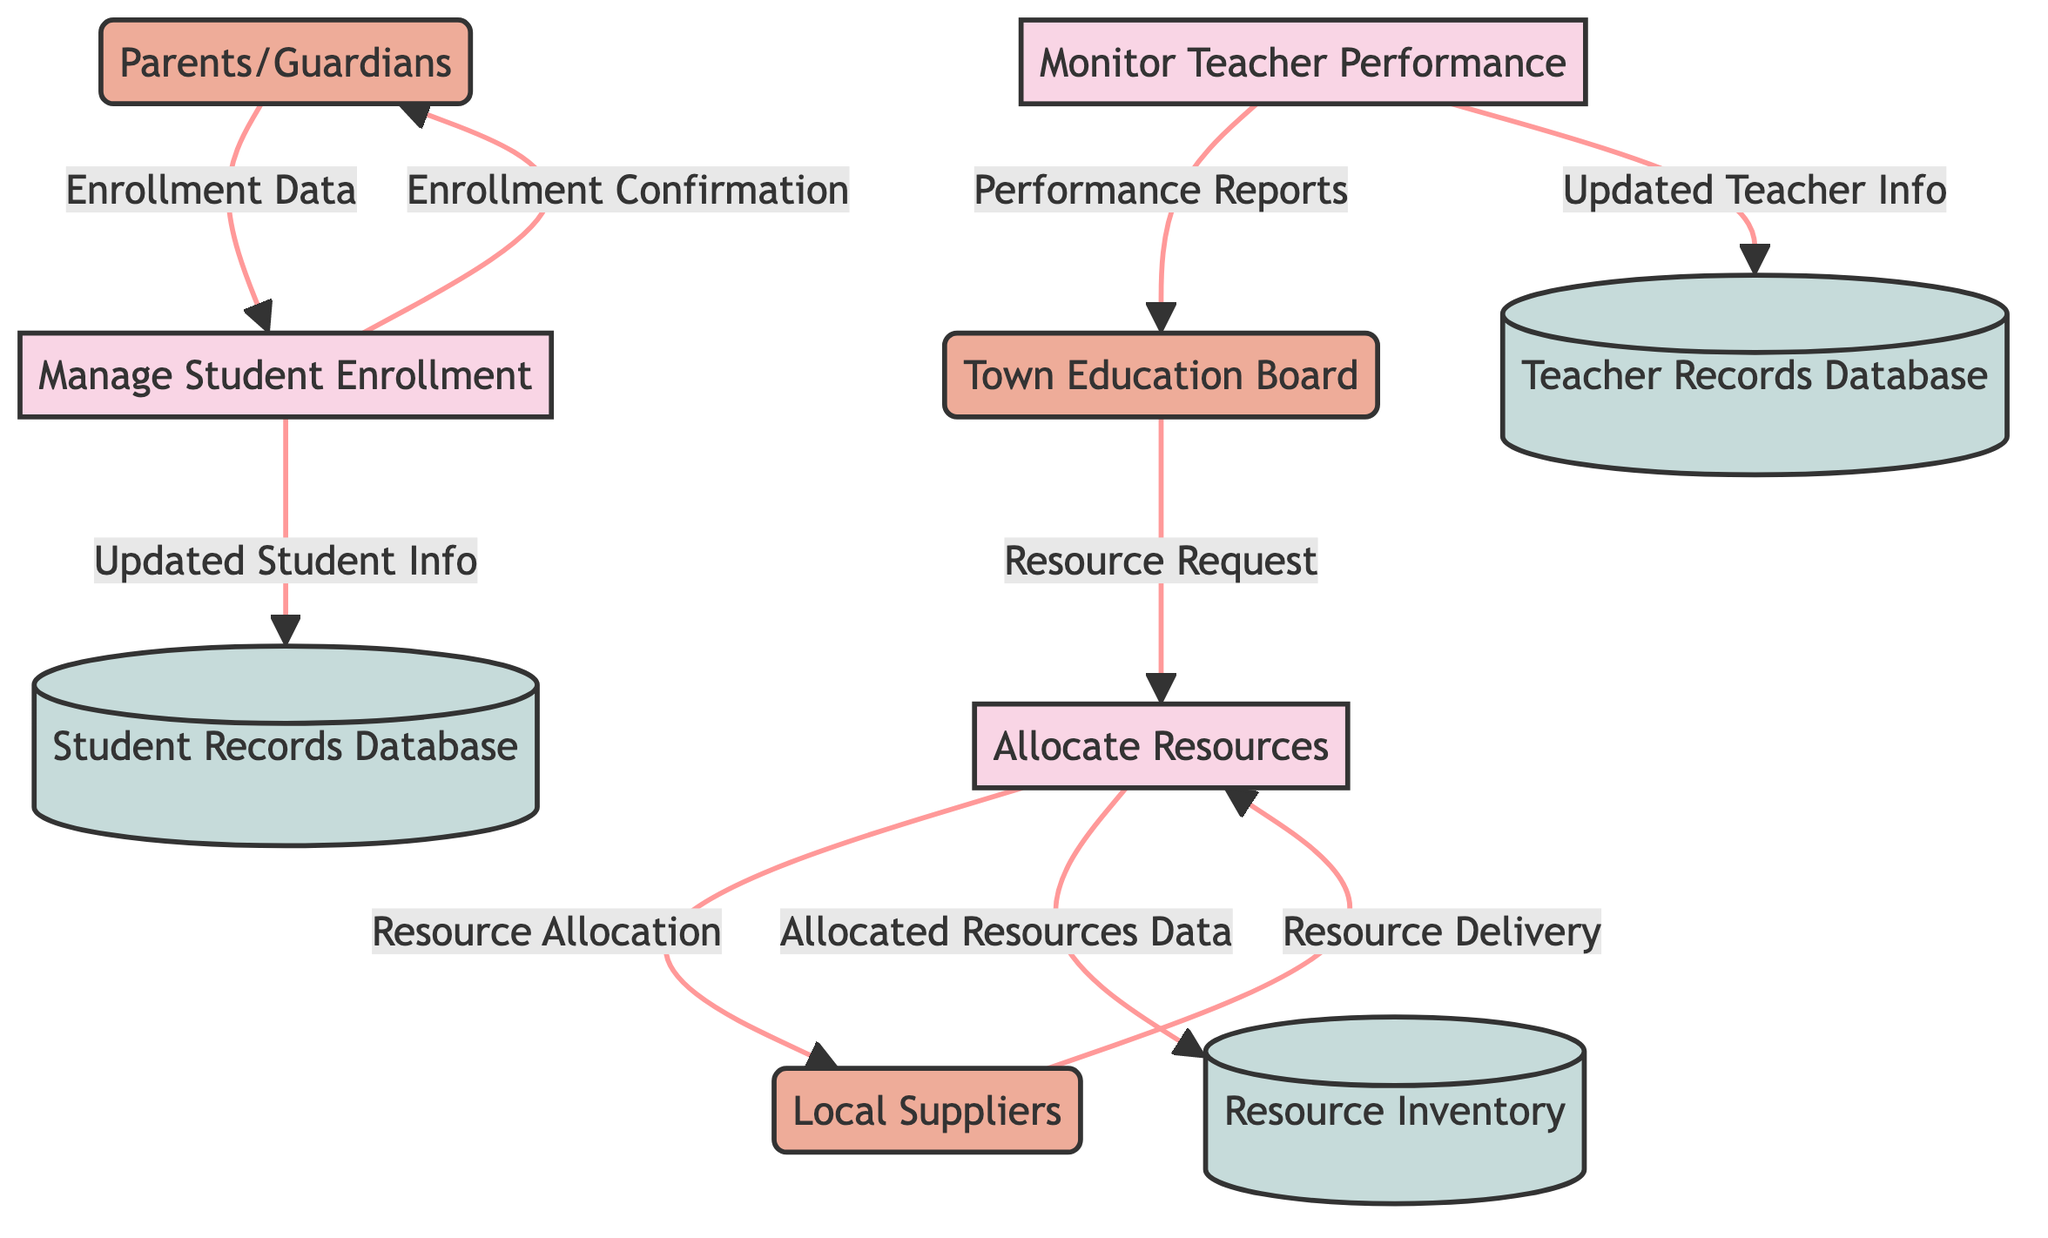What are the three main processes in the diagram? The three main processes identified in the diagram are "Allocate Resources," "Manage Student Enrollment," and "Monitor Teacher Performance." These are listed clearly as the primary functions of the town’s early education system.
Answer: Allocate Resources, Manage Student Enrollment, Monitor Teacher Performance Which entity interacts with the "Manage Student Enrollment" process? The entity that interacts with the "Manage Student Enrollment" process is "Parents/Guardians." They provide the necessary enrollment data and receive confirmation.
Answer: Parents/Guardians How many data stores are present in the diagram? The diagram includes three data stores, which are "Student Records Database," "Teacher Records Database," and "Resource Inventory." Each serves a distinct purpose in storing relevant information.
Answer: Three What type of data flow is shown between "Allocate Resources" and "Resource Inventory"? The data flow between "Allocate Resources" and "Resource Inventory" is labeled as "Allocated Resources Data." This flow indicates that details about the resources allocated are updated in the inventory.
Answer: Allocated Resources Data What information do "Parents/Guardians" receive after enrollment? After enrollment, "Parents/Guardians" receive "Enrollment Confirmation," which consists of acknowledgment and details of the successful student enrollment.
Answer: Enrollment Confirmation How many external entities are represented in the diagram? There are three external entities represented in the diagram, which include "Town Education Board," "Parents/Guardians," and "Local Suppliers." These entities interact with the processes in the education system.
Answer: Three What does the data flow "Performance Reports" describe? The "Performance Reports" data flow describes the reports on teacher performance generated by the "Monitor Teacher Performance" process, which are then sent to the "Town Education Board" for review.
Answer: Reports on teacher performance Which entity requests resources in the process? The "Town Education Board" is the entity that requests resources in the process. This is done through the "Resource Request" data flow directed towards the "Allocate Resources" process.
Answer: Town Education Board What type of information is stored in the "Teacher Records Database"? The "Teacher Records Database" stores details of teacher performance, including their employment details, performance reviews, and credentials to maintain comprehensive records.
Answer: Teacher performance details 